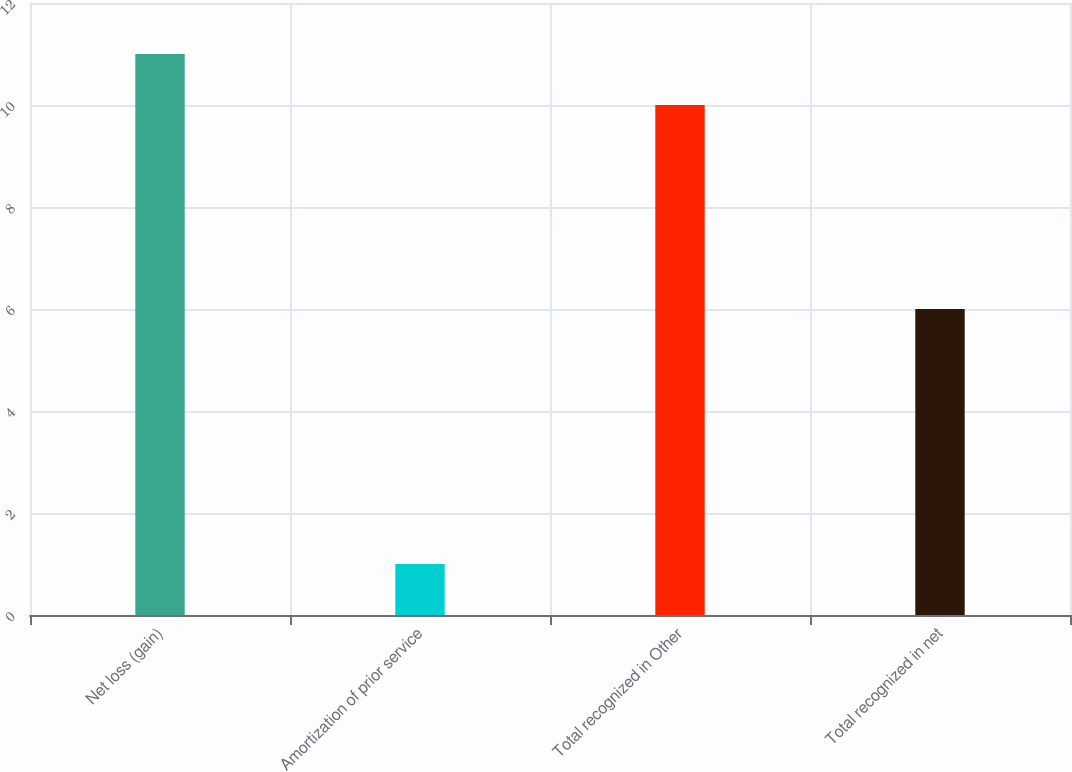<chart> <loc_0><loc_0><loc_500><loc_500><bar_chart><fcel>Net loss (gain)<fcel>Amortization of prior service<fcel>Total recognized in Other<fcel>Total recognized in net<nl><fcel>11<fcel>1<fcel>10<fcel>6<nl></chart> 